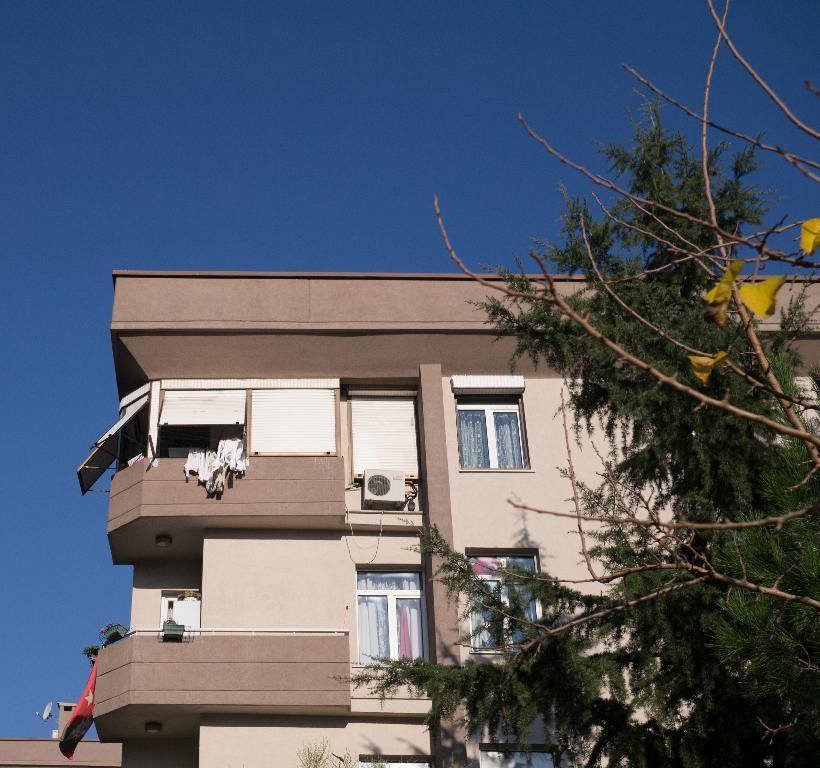What type of natural element is present in the image? There is a tree in the image. What structure is located behind the tree? There is a building behind the tree, which appears to be an apartment. What can be seen in the background of the image? The sky is visible in the background of the image. Is there a kite flying in the sky in the image? No, there is no kite visible in the image. What stage of development is the apartment building in the image? The provided facts do not give any information about the development stage of the apartment building. 